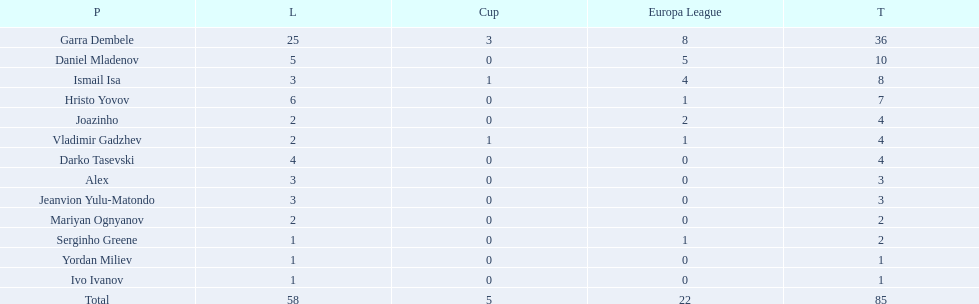What players did not score in all 3 competitions? Daniel Mladenov, Hristo Yovov, Joazinho, Darko Tasevski, Alex, Jeanvion Yulu-Matondo, Mariyan Ognyanov, Serginho Greene, Yordan Miliev, Ivo Ivanov. Which of those did not have total more then 5? Darko Tasevski, Alex, Jeanvion Yulu-Matondo, Mariyan Ognyanov, Serginho Greene, Yordan Miliev, Ivo Ivanov. Which ones scored more then 1 total? Darko Tasevski, Alex, Jeanvion Yulu-Matondo, Mariyan Ognyanov. Which of these player had the lease league points? Mariyan Ognyanov. 